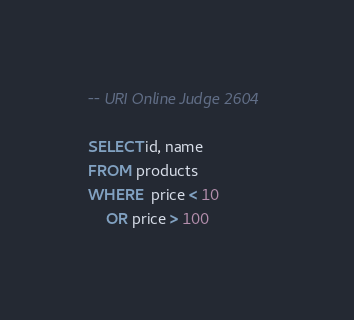Convert code to text. <code><loc_0><loc_0><loc_500><loc_500><_SQL_>-- URI Online Judge 2604

SELECT id, name
FROM products
WHERE  price < 10
    OR price > 100 </code> 